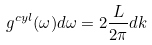<formula> <loc_0><loc_0><loc_500><loc_500>g ^ { c y l } ( \omega ) d \omega = 2 \frac { L } { 2 \pi } d k</formula> 